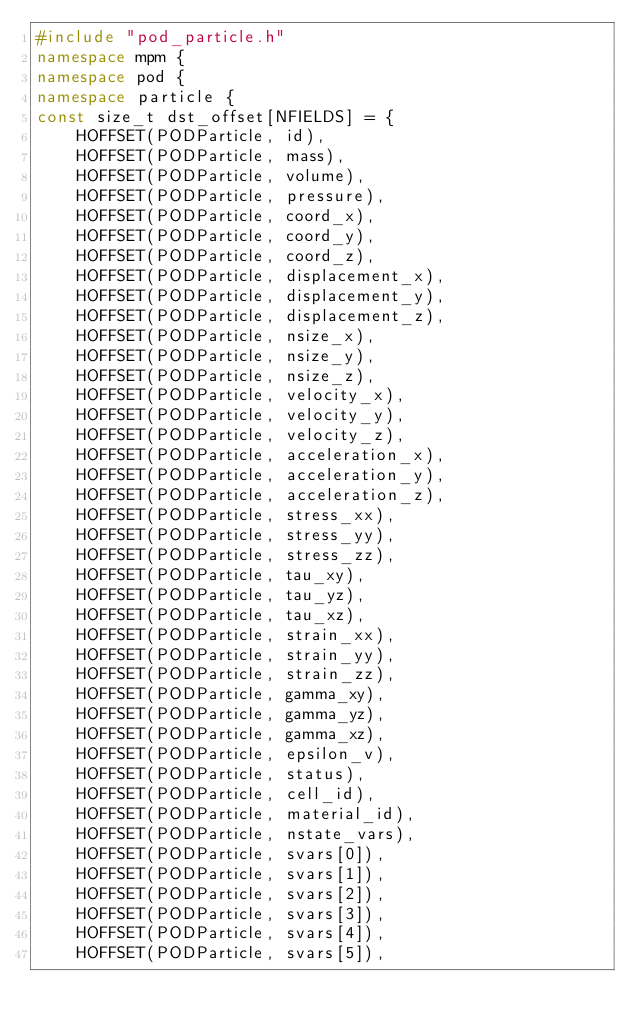Convert code to text. <code><loc_0><loc_0><loc_500><loc_500><_C++_>#include "pod_particle.h"
namespace mpm {
namespace pod {
namespace particle {
const size_t dst_offset[NFIELDS] = {
    HOFFSET(PODParticle, id),
    HOFFSET(PODParticle, mass),
    HOFFSET(PODParticle, volume),
    HOFFSET(PODParticle, pressure),
    HOFFSET(PODParticle, coord_x),
    HOFFSET(PODParticle, coord_y),
    HOFFSET(PODParticle, coord_z),
    HOFFSET(PODParticle, displacement_x),
    HOFFSET(PODParticle, displacement_y),
    HOFFSET(PODParticle, displacement_z),
    HOFFSET(PODParticle, nsize_x),
    HOFFSET(PODParticle, nsize_y),
    HOFFSET(PODParticle, nsize_z),
    HOFFSET(PODParticle, velocity_x),
    HOFFSET(PODParticle, velocity_y),
    HOFFSET(PODParticle, velocity_z),
    HOFFSET(PODParticle, acceleration_x),
    HOFFSET(PODParticle, acceleration_y),
    HOFFSET(PODParticle, acceleration_z),
    HOFFSET(PODParticle, stress_xx),
    HOFFSET(PODParticle, stress_yy),
    HOFFSET(PODParticle, stress_zz),
    HOFFSET(PODParticle, tau_xy),
    HOFFSET(PODParticle, tau_yz),
    HOFFSET(PODParticle, tau_xz),
    HOFFSET(PODParticle, strain_xx),
    HOFFSET(PODParticle, strain_yy),
    HOFFSET(PODParticle, strain_zz),
    HOFFSET(PODParticle, gamma_xy),
    HOFFSET(PODParticle, gamma_yz),
    HOFFSET(PODParticle, gamma_xz),
    HOFFSET(PODParticle, epsilon_v),
    HOFFSET(PODParticle, status),
    HOFFSET(PODParticle, cell_id),
    HOFFSET(PODParticle, material_id),
    HOFFSET(PODParticle, nstate_vars),
    HOFFSET(PODParticle, svars[0]),
    HOFFSET(PODParticle, svars[1]),
    HOFFSET(PODParticle, svars[2]),
    HOFFSET(PODParticle, svars[3]),
    HOFFSET(PODParticle, svars[4]),
    HOFFSET(PODParticle, svars[5]),</code> 